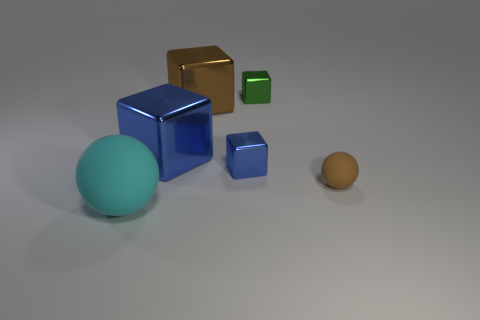What number of objects are in front of the large brown metallic block on the right side of the ball to the left of the small brown matte sphere?
Your answer should be very brief. 4. There is a brown shiny thing that is the same shape as the tiny blue metal object; what is its size?
Provide a succinct answer. Large. Is there any other thing that is the same size as the green cube?
Ensure brevity in your answer.  Yes. Is the number of big blue cubes that are to the right of the big brown cube less than the number of spheres?
Your answer should be compact. Yes. Is the cyan thing the same shape as the brown matte thing?
Provide a succinct answer. Yes. There is another thing that is the same shape as the large cyan thing; what is its color?
Offer a terse response. Brown. What number of tiny blocks have the same color as the big matte thing?
Make the answer very short. 0. What number of things are brown objects that are on the left side of the green cube or cyan matte spheres?
Your response must be concise. 2. What size is the blue shiny cube that is on the right side of the brown shiny block?
Your answer should be compact. Small. Is the number of tiny brown spheres less than the number of balls?
Offer a very short reply. Yes. 